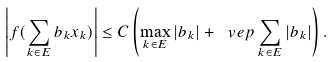Convert formula to latex. <formula><loc_0><loc_0><loc_500><loc_500>\left | f ( \sum _ { k \in E } b _ { k } x _ { k } ) \right | \leq C \left ( \max _ { k \in E } | b _ { k } | + \ v e p \sum _ { k \in E } | b _ { k } | \right ) .</formula> 